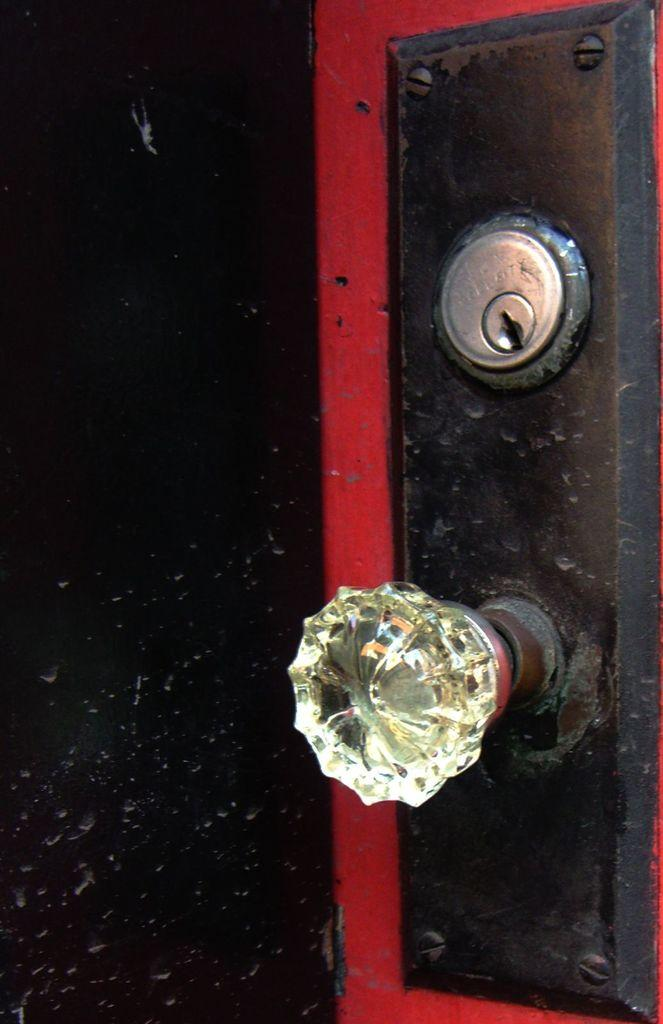What is the main object in the image? There is a holder in the image. What is the purpose of the key panel in the image? The key panel is likely used for unlocking or locking the holder. Can you describe the black object with red color strips in the image? The black object with red color strips is a part of the holder, possibly indicating a handle or a lock mechanism. What type of music can be heard playing from the silver apple in the image? There is no silver apple or music present in the image. 